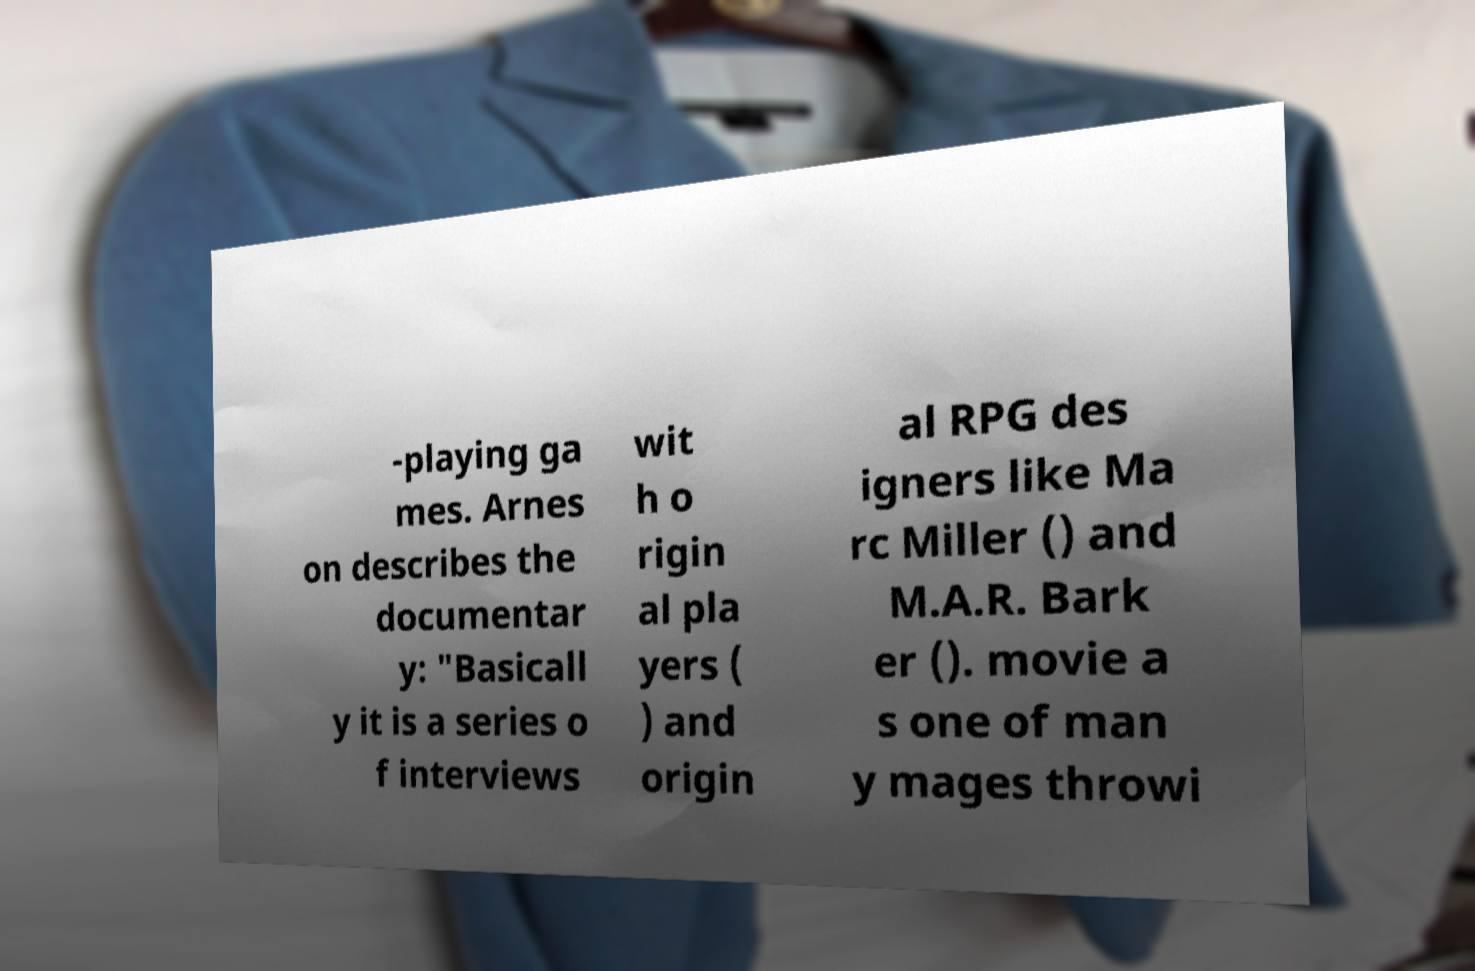There's text embedded in this image that I need extracted. Can you transcribe it verbatim? -playing ga mes. Arnes on describes the documentar y: "Basicall y it is a series o f interviews wit h o rigin al pla yers ( ) and origin al RPG des igners like Ma rc Miller () and M.A.R. Bark er (). movie a s one of man y mages throwi 